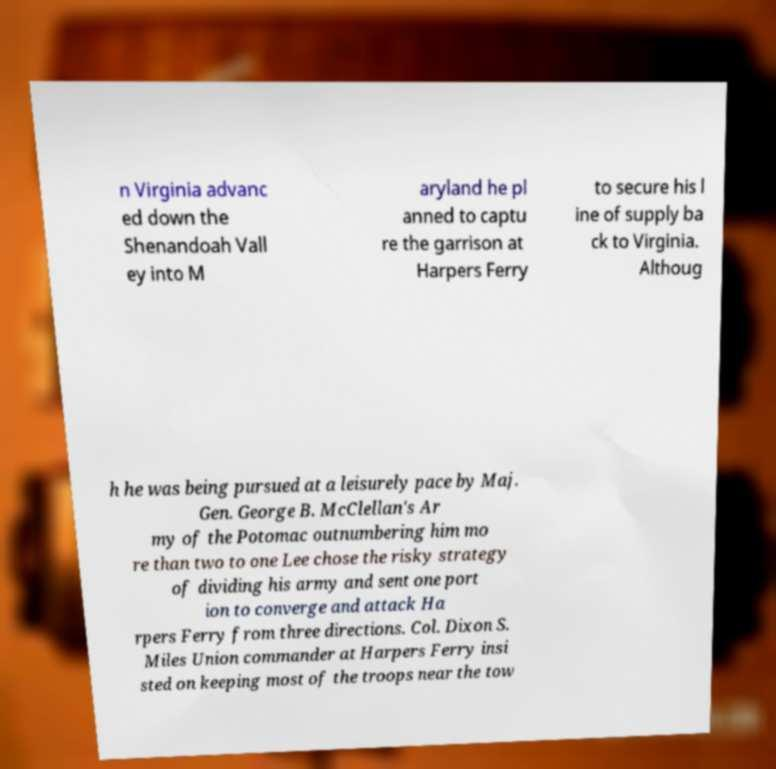Could you extract and type out the text from this image? n Virginia advanc ed down the Shenandoah Vall ey into M aryland he pl anned to captu re the garrison at Harpers Ferry to secure his l ine of supply ba ck to Virginia. Althoug h he was being pursued at a leisurely pace by Maj. Gen. George B. McClellan's Ar my of the Potomac outnumbering him mo re than two to one Lee chose the risky strategy of dividing his army and sent one port ion to converge and attack Ha rpers Ferry from three directions. Col. Dixon S. Miles Union commander at Harpers Ferry insi sted on keeping most of the troops near the tow 